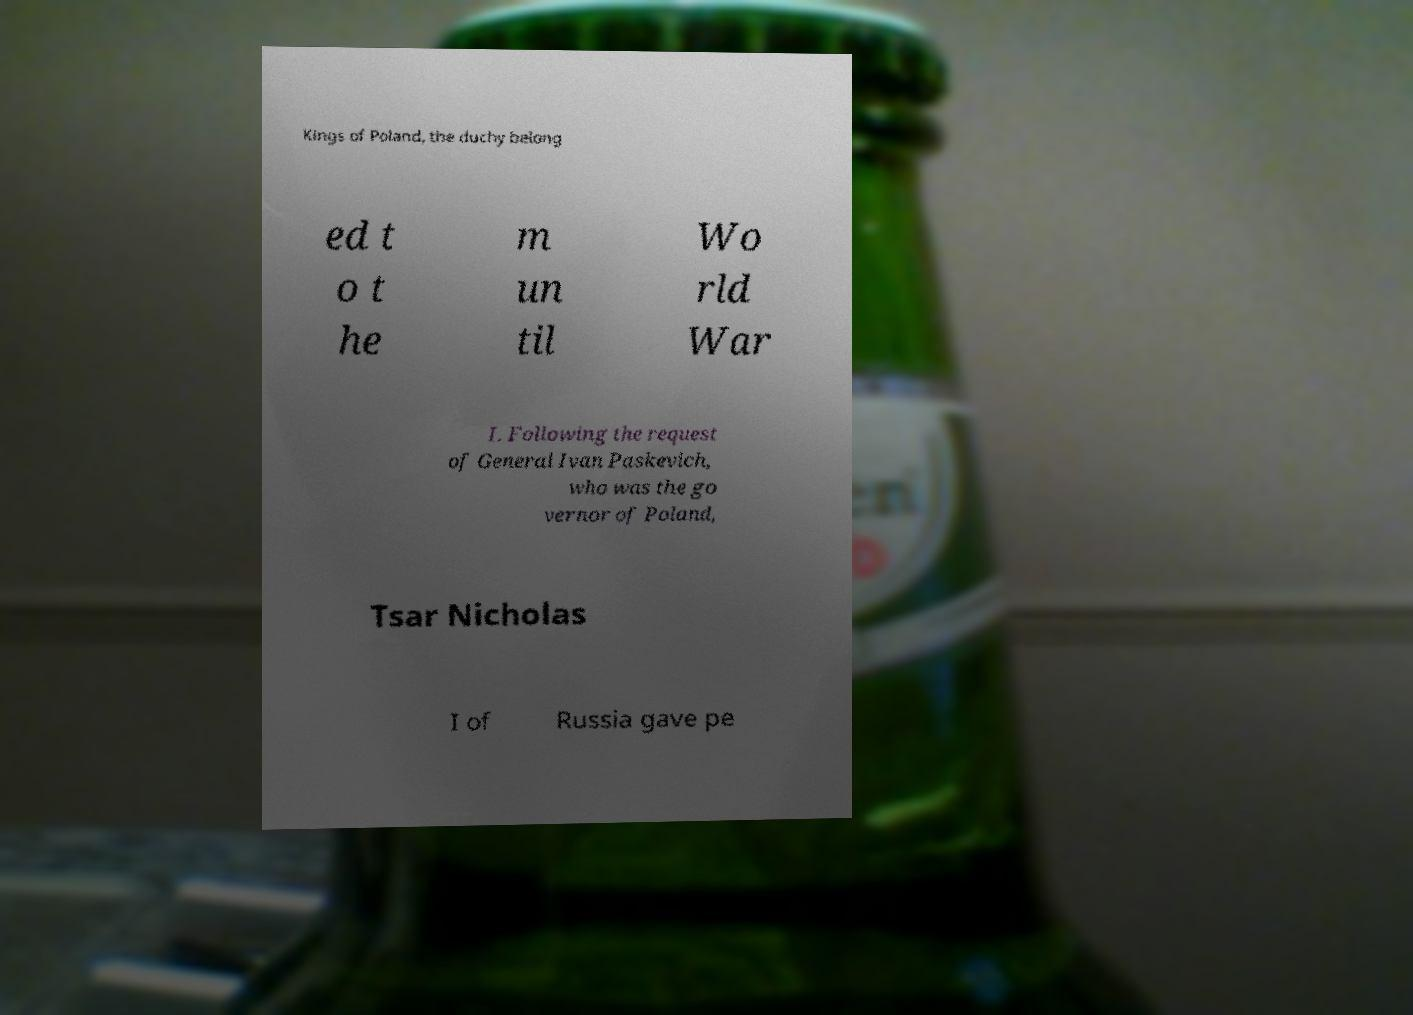Could you extract and type out the text from this image? Kings of Poland, the duchy belong ed t o t he m un til Wo rld War I. Following the request of General Ivan Paskevich, who was the go vernor of Poland, Tsar Nicholas I of Russia gave pe 